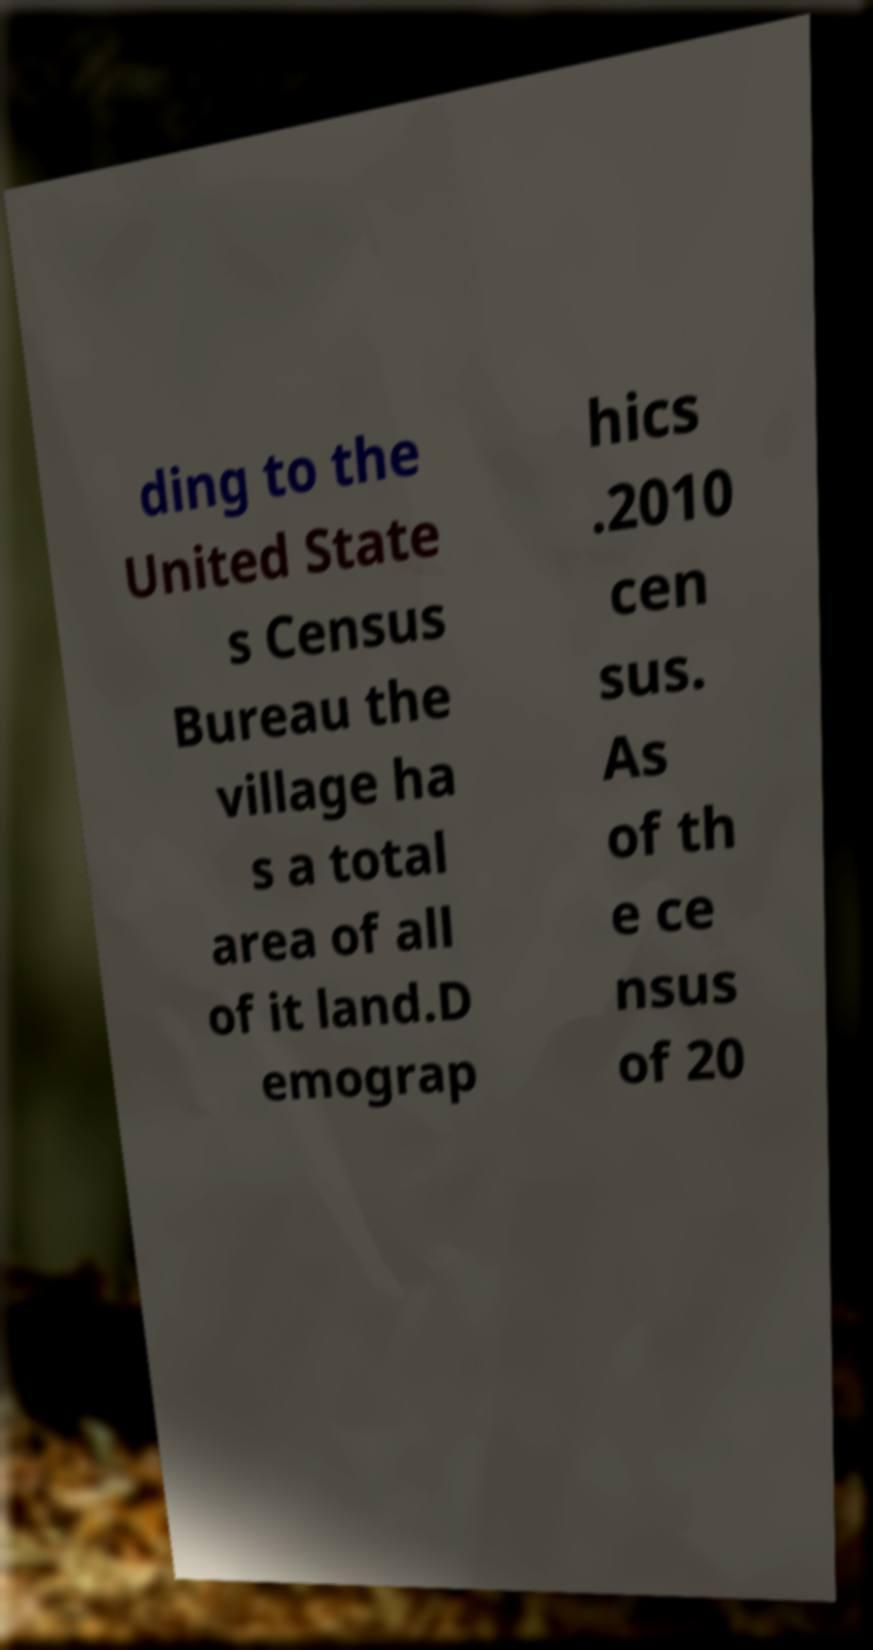Could you assist in decoding the text presented in this image and type it out clearly? ding to the United State s Census Bureau the village ha s a total area of all of it land.D emograp hics .2010 cen sus. As of th e ce nsus of 20 